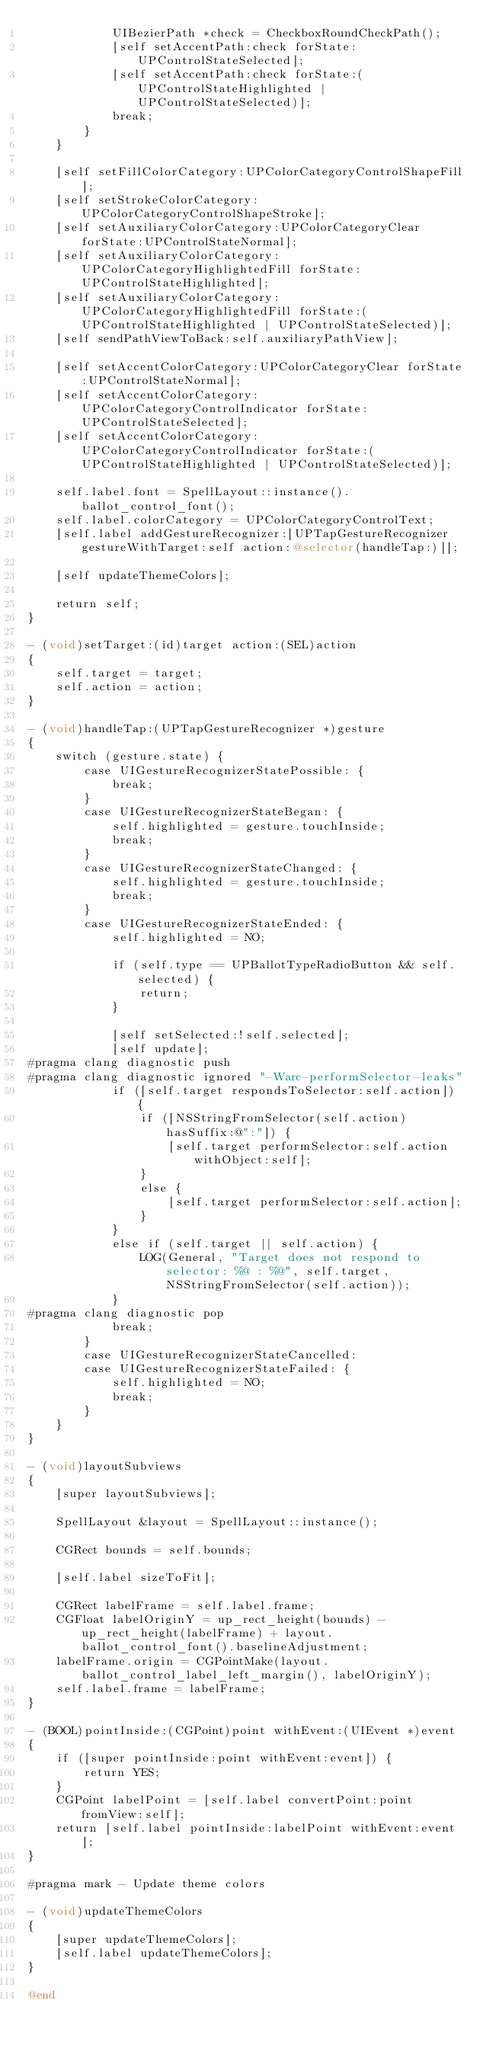<code> <loc_0><loc_0><loc_500><loc_500><_ObjectiveC_>            UIBezierPath *check = CheckboxRoundCheckPath();
            [self setAccentPath:check forState:UPControlStateSelected];
            [self setAccentPath:check forState:(UPControlStateHighlighted | UPControlStateSelected)];
            break;
        }
    }

    [self setFillColorCategory:UPColorCategoryControlShapeFill];
    [self setStrokeColorCategory:UPColorCategoryControlShapeStroke];
    [self setAuxiliaryColorCategory:UPColorCategoryClear forState:UPControlStateNormal];
    [self setAuxiliaryColorCategory:UPColorCategoryHighlightedFill forState:UPControlStateHighlighted];
    [self setAuxiliaryColorCategory:UPColorCategoryHighlightedFill forState:(UPControlStateHighlighted | UPControlStateSelected)];
    [self sendPathViewToBack:self.auxiliaryPathView];
    
    [self setAccentColorCategory:UPColorCategoryClear forState:UPControlStateNormal];
    [self setAccentColorCategory:UPColorCategoryControlIndicator forState:UPControlStateSelected];
    [self setAccentColorCategory:UPColorCategoryControlIndicator forState:(UPControlStateHighlighted | UPControlStateSelected)];
    
    self.label.font = SpellLayout::instance().ballot_control_font();
    self.label.colorCategory = UPColorCategoryControlText;
    [self.label addGestureRecognizer:[UPTapGestureRecognizer gestureWithTarget:self action:@selector(handleTap:)]];

    [self updateThemeColors];
    
    return self;
}

- (void)setTarget:(id)target action:(SEL)action
{
    self.target = target;
    self.action = action;
}

- (void)handleTap:(UPTapGestureRecognizer *)gesture
{
    switch (gesture.state) {
        case UIGestureRecognizerStatePossible: {
            break;
        }
        case UIGestureRecognizerStateBegan: {
            self.highlighted = gesture.touchInside;
            break;
        }
        case UIGestureRecognizerStateChanged: {
            self.highlighted = gesture.touchInside;
            break;
        }
        case UIGestureRecognizerStateEnded: {
            self.highlighted = NO;
            
            if (self.type == UPBallotTypeRadioButton && self.selected) {
                return;
            }
            
            [self setSelected:!self.selected];
            [self update];
#pragma clang diagnostic push
#pragma clang diagnostic ignored "-Warc-performSelector-leaks"
            if ([self.target respondsToSelector:self.action]) {
                if ([NSStringFromSelector(self.action) hasSuffix:@":"]) {
                    [self.target performSelector:self.action withObject:self];
                }
                else {
                    [self.target performSelector:self.action];
                }
            }
            else if (self.target || self.action) {
                LOG(General, "Target does not respond to selector: %@ : %@", self.target, NSStringFromSelector(self.action));
            }
#pragma clang diagnostic pop
            break;
        }
        case UIGestureRecognizerStateCancelled:
        case UIGestureRecognizerStateFailed: {
            self.highlighted = NO;
            break;
        }
    }
}

- (void)layoutSubviews
{
    [super layoutSubviews];
    
    SpellLayout &layout = SpellLayout::instance();

    CGRect bounds = self.bounds;
    
    [self.label sizeToFit];
    
    CGRect labelFrame = self.label.frame;
    CGFloat labelOriginY = up_rect_height(bounds) - up_rect_height(labelFrame) + layout.ballot_control_font().baselineAdjustment;
    labelFrame.origin = CGPointMake(layout.ballot_control_label_left_margin(), labelOriginY);
    self.label.frame = labelFrame;
}

- (BOOL)pointInside:(CGPoint)point withEvent:(UIEvent *)event
{
    if ([super pointInside:point withEvent:event]) {
        return YES;
    }
    CGPoint labelPoint = [self.label convertPoint:point fromView:self];
    return [self.label pointInside:labelPoint withEvent:event];
}

#pragma mark - Update theme colors

- (void)updateThemeColors
{
    [super updateThemeColors];
    [self.label updateThemeColors];
}

@end
</code> 